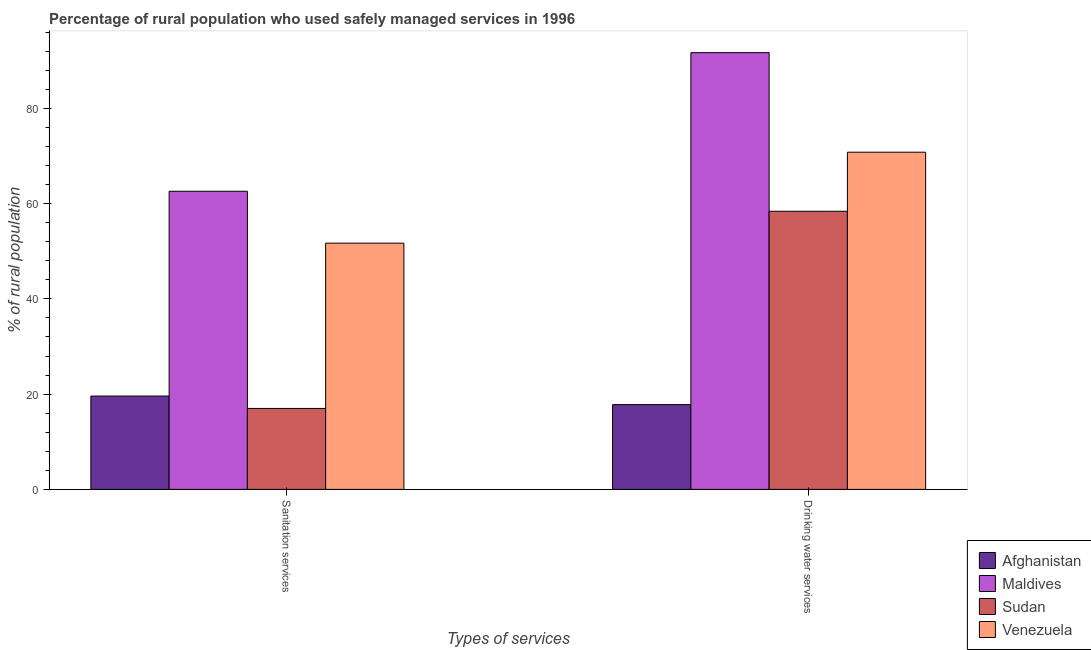How many groups of bars are there?
Provide a succinct answer. 2. How many bars are there on the 2nd tick from the right?
Keep it short and to the point. 4. What is the label of the 1st group of bars from the left?
Provide a short and direct response. Sanitation services. What is the percentage of rural population who used sanitation services in Sudan?
Give a very brief answer. 17. Across all countries, what is the maximum percentage of rural population who used sanitation services?
Your answer should be very brief. 62.6. Across all countries, what is the minimum percentage of rural population who used drinking water services?
Offer a terse response. 17.8. In which country was the percentage of rural population who used drinking water services maximum?
Offer a terse response. Maldives. In which country was the percentage of rural population who used drinking water services minimum?
Provide a short and direct response. Afghanistan. What is the total percentage of rural population who used sanitation services in the graph?
Provide a short and direct response. 150.9. What is the difference between the percentage of rural population who used sanitation services in Maldives and that in Sudan?
Offer a very short reply. 45.6. What is the difference between the percentage of rural population who used sanitation services in Maldives and the percentage of rural population who used drinking water services in Venezuela?
Ensure brevity in your answer.  -8.2. What is the average percentage of rural population who used drinking water services per country?
Provide a succinct answer. 59.67. What is the difference between the percentage of rural population who used sanitation services and percentage of rural population who used drinking water services in Afghanistan?
Keep it short and to the point. 1.8. In how many countries, is the percentage of rural population who used sanitation services greater than 28 %?
Provide a succinct answer. 2. What is the ratio of the percentage of rural population who used sanitation services in Afghanistan to that in Sudan?
Your answer should be very brief. 1.15. Is the percentage of rural population who used sanitation services in Sudan less than that in Afghanistan?
Give a very brief answer. Yes. In how many countries, is the percentage of rural population who used sanitation services greater than the average percentage of rural population who used sanitation services taken over all countries?
Ensure brevity in your answer.  2. What does the 1st bar from the left in Drinking water services represents?
Ensure brevity in your answer.  Afghanistan. What does the 1st bar from the right in Sanitation services represents?
Offer a very short reply. Venezuela. How many bars are there?
Ensure brevity in your answer.  8. How many countries are there in the graph?
Provide a short and direct response. 4. What is the difference between two consecutive major ticks on the Y-axis?
Provide a short and direct response. 20. Are the values on the major ticks of Y-axis written in scientific E-notation?
Offer a very short reply. No. Where does the legend appear in the graph?
Provide a short and direct response. Bottom right. How many legend labels are there?
Make the answer very short. 4. What is the title of the graph?
Your answer should be very brief. Percentage of rural population who used safely managed services in 1996. What is the label or title of the X-axis?
Ensure brevity in your answer.  Types of services. What is the label or title of the Y-axis?
Your response must be concise. % of rural population. What is the % of rural population of Afghanistan in Sanitation services?
Your response must be concise. 19.6. What is the % of rural population of Maldives in Sanitation services?
Provide a short and direct response. 62.6. What is the % of rural population of Sudan in Sanitation services?
Keep it short and to the point. 17. What is the % of rural population of Venezuela in Sanitation services?
Your response must be concise. 51.7. What is the % of rural population in Afghanistan in Drinking water services?
Offer a terse response. 17.8. What is the % of rural population in Maldives in Drinking water services?
Offer a terse response. 91.7. What is the % of rural population of Sudan in Drinking water services?
Keep it short and to the point. 58.4. What is the % of rural population in Venezuela in Drinking water services?
Keep it short and to the point. 70.8. Across all Types of services, what is the maximum % of rural population of Afghanistan?
Keep it short and to the point. 19.6. Across all Types of services, what is the maximum % of rural population of Maldives?
Provide a succinct answer. 91.7. Across all Types of services, what is the maximum % of rural population of Sudan?
Give a very brief answer. 58.4. Across all Types of services, what is the maximum % of rural population in Venezuela?
Your answer should be compact. 70.8. Across all Types of services, what is the minimum % of rural population of Afghanistan?
Make the answer very short. 17.8. Across all Types of services, what is the minimum % of rural population in Maldives?
Offer a terse response. 62.6. Across all Types of services, what is the minimum % of rural population in Sudan?
Make the answer very short. 17. Across all Types of services, what is the minimum % of rural population of Venezuela?
Keep it short and to the point. 51.7. What is the total % of rural population in Afghanistan in the graph?
Your response must be concise. 37.4. What is the total % of rural population in Maldives in the graph?
Give a very brief answer. 154.3. What is the total % of rural population in Sudan in the graph?
Your answer should be compact. 75.4. What is the total % of rural population in Venezuela in the graph?
Your answer should be compact. 122.5. What is the difference between the % of rural population in Maldives in Sanitation services and that in Drinking water services?
Make the answer very short. -29.1. What is the difference between the % of rural population in Sudan in Sanitation services and that in Drinking water services?
Keep it short and to the point. -41.4. What is the difference between the % of rural population in Venezuela in Sanitation services and that in Drinking water services?
Provide a short and direct response. -19.1. What is the difference between the % of rural population in Afghanistan in Sanitation services and the % of rural population in Maldives in Drinking water services?
Provide a short and direct response. -72.1. What is the difference between the % of rural population of Afghanistan in Sanitation services and the % of rural population of Sudan in Drinking water services?
Provide a succinct answer. -38.8. What is the difference between the % of rural population in Afghanistan in Sanitation services and the % of rural population in Venezuela in Drinking water services?
Keep it short and to the point. -51.2. What is the difference between the % of rural population in Maldives in Sanitation services and the % of rural population in Sudan in Drinking water services?
Offer a very short reply. 4.2. What is the difference between the % of rural population in Maldives in Sanitation services and the % of rural population in Venezuela in Drinking water services?
Offer a terse response. -8.2. What is the difference between the % of rural population of Sudan in Sanitation services and the % of rural population of Venezuela in Drinking water services?
Your answer should be compact. -53.8. What is the average % of rural population of Afghanistan per Types of services?
Offer a very short reply. 18.7. What is the average % of rural population in Maldives per Types of services?
Offer a very short reply. 77.15. What is the average % of rural population in Sudan per Types of services?
Make the answer very short. 37.7. What is the average % of rural population of Venezuela per Types of services?
Offer a terse response. 61.25. What is the difference between the % of rural population of Afghanistan and % of rural population of Maldives in Sanitation services?
Make the answer very short. -43. What is the difference between the % of rural population in Afghanistan and % of rural population in Venezuela in Sanitation services?
Offer a very short reply. -32.1. What is the difference between the % of rural population in Maldives and % of rural population in Sudan in Sanitation services?
Make the answer very short. 45.6. What is the difference between the % of rural population in Maldives and % of rural population in Venezuela in Sanitation services?
Offer a terse response. 10.9. What is the difference between the % of rural population of Sudan and % of rural population of Venezuela in Sanitation services?
Keep it short and to the point. -34.7. What is the difference between the % of rural population in Afghanistan and % of rural population in Maldives in Drinking water services?
Offer a very short reply. -73.9. What is the difference between the % of rural population in Afghanistan and % of rural population in Sudan in Drinking water services?
Provide a succinct answer. -40.6. What is the difference between the % of rural population in Afghanistan and % of rural population in Venezuela in Drinking water services?
Make the answer very short. -53. What is the difference between the % of rural population in Maldives and % of rural population in Sudan in Drinking water services?
Offer a terse response. 33.3. What is the difference between the % of rural population in Maldives and % of rural population in Venezuela in Drinking water services?
Ensure brevity in your answer.  20.9. What is the ratio of the % of rural population in Afghanistan in Sanitation services to that in Drinking water services?
Provide a succinct answer. 1.1. What is the ratio of the % of rural population of Maldives in Sanitation services to that in Drinking water services?
Provide a short and direct response. 0.68. What is the ratio of the % of rural population in Sudan in Sanitation services to that in Drinking water services?
Provide a short and direct response. 0.29. What is the ratio of the % of rural population in Venezuela in Sanitation services to that in Drinking water services?
Provide a short and direct response. 0.73. What is the difference between the highest and the second highest % of rural population in Afghanistan?
Make the answer very short. 1.8. What is the difference between the highest and the second highest % of rural population of Maldives?
Provide a short and direct response. 29.1. What is the difference between the highest and the second highest % of rural population in Sudan?
Provide a succinct answer. 41.4. What is the difference between the highest and the lowest % of rural population of Afghanistan?
Provide a succinct answer. 1.8. What is the difference between the highest and the lowest % of rural population of Maldives?
Make the answer very short. 29.1. What is the difference between the highest and the lowest % of rural population of Sudan?
Your answer should be very brief. 41.4. What is the difference between the highest and the lowest % of rural population in Venezuela?
Provide a short and direct response. 19.1. 